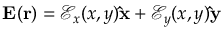Convert formula to latex. <formula><loc_0><loc_0><loc_500><loc_500>E ( r ) = \mathcal { E } _ { x } ( x , y ) \hat { x } + \mathcal { E } _ { y } ( x , y ) \hat { y }</formula> 